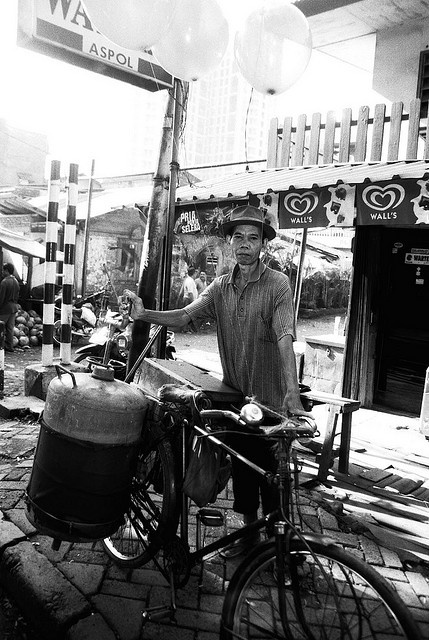Describe the objects in this image and their specific colors. I can see bicycle in white, black, gray, darkgray, and lightgray tones, people in white, gray, black, darkgray, and lightgray tones, handbag in white, black, gray, and lightgray tones, people in white, black, gray, darkgray, and lightgray tones, and motorcycle in white, black, gray, and darkgray tones in this image. 